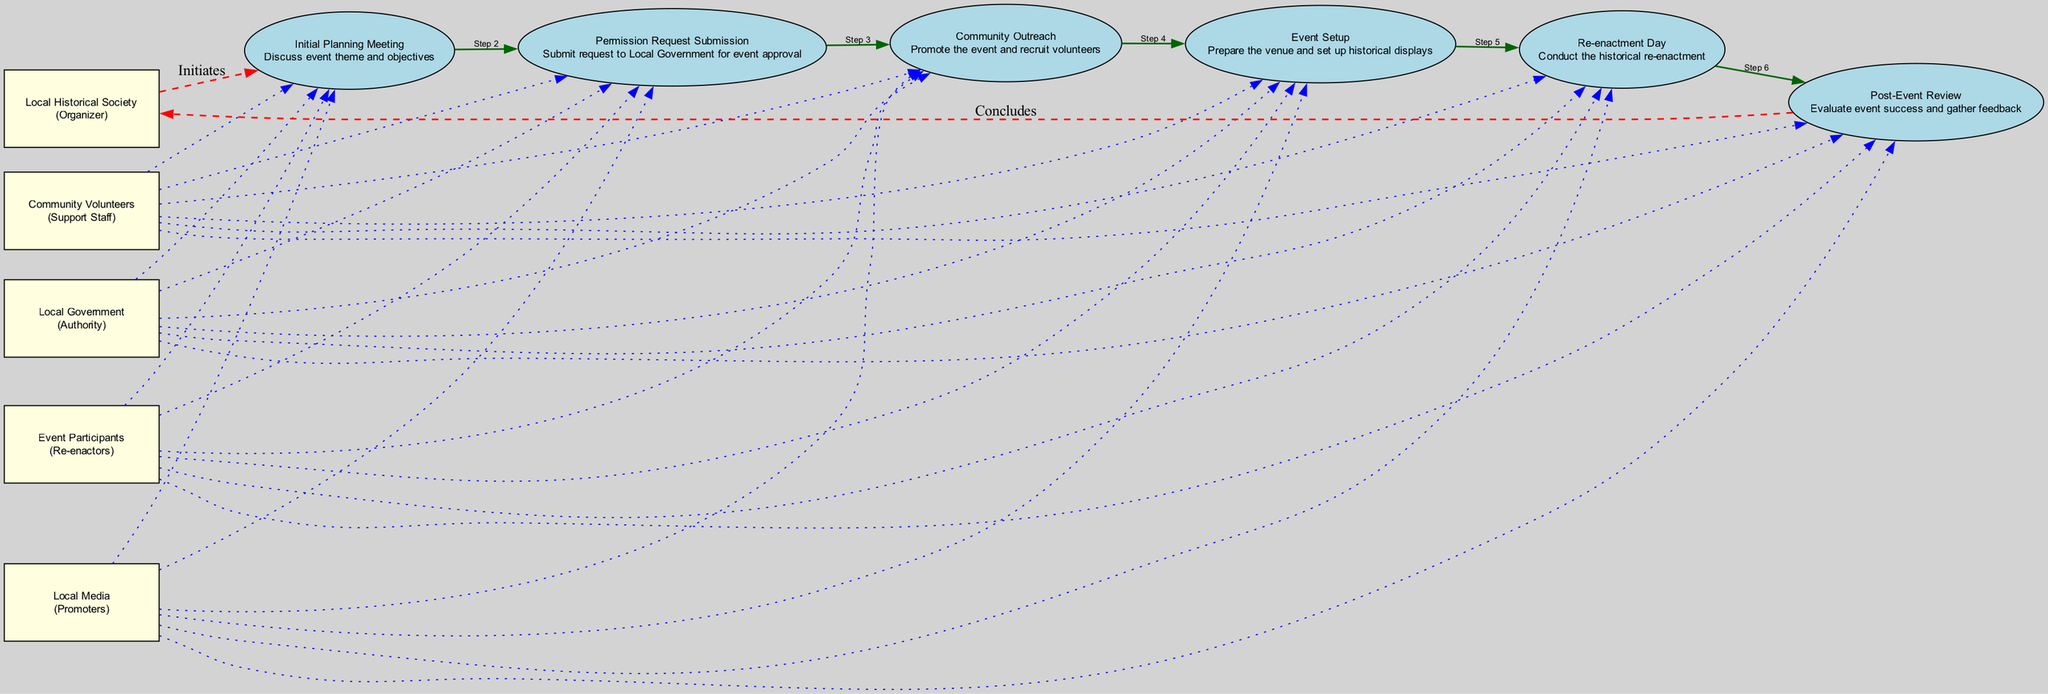What is the role of the Local Historical Society? The diagram indicates that the Local Historical Society is the Organizer, as shown in the participant list.
Answer: Organizer How many events are listed in the diagram? By counting the events section in the diagram, we see there are six distinct events detailed.
Answer: Six What initiates the sequence of events? The first event listed is the Initial Planning Meeting, which indicates the beginning of the event sequence.
Answer: Initial Planning Meeting Which participant is involved in the post-event review? The Post-Event Review is the final event, and the Local Historical Society, as the Organizer, is involved in this evaluation process.
Answer: Local Historical Society What type of relationship connects the Local Government to the Permission Request Submission? A dashed line indicates that the Local Government is involved through a request for permission, showcasing a 'approves' interaction related to that event.
Answer: Approves What is the final step in the event sequence? The final event in the sequence diagram is the Post-Event Review, concluding the coordination process.
Answer: Post-Event Review How many participants are connected to the Re-enactment Day? The diagram shows that all five participants connect to the Re-enactment Day event, reflecting their roles during that event.
Answer: Five What type of line connects the Community Volunteers to the Event Setup? The Community Volunteers are connected by a dotted line to the Event Setup, indicating their supportive role in that context.
Answer: Dotted Line Which event does the Local Media promote? According to the diagram, the Local Media promotes the event during the Community Outreach stage, encouraging participant recruitment.
Answer: Community Outreach 